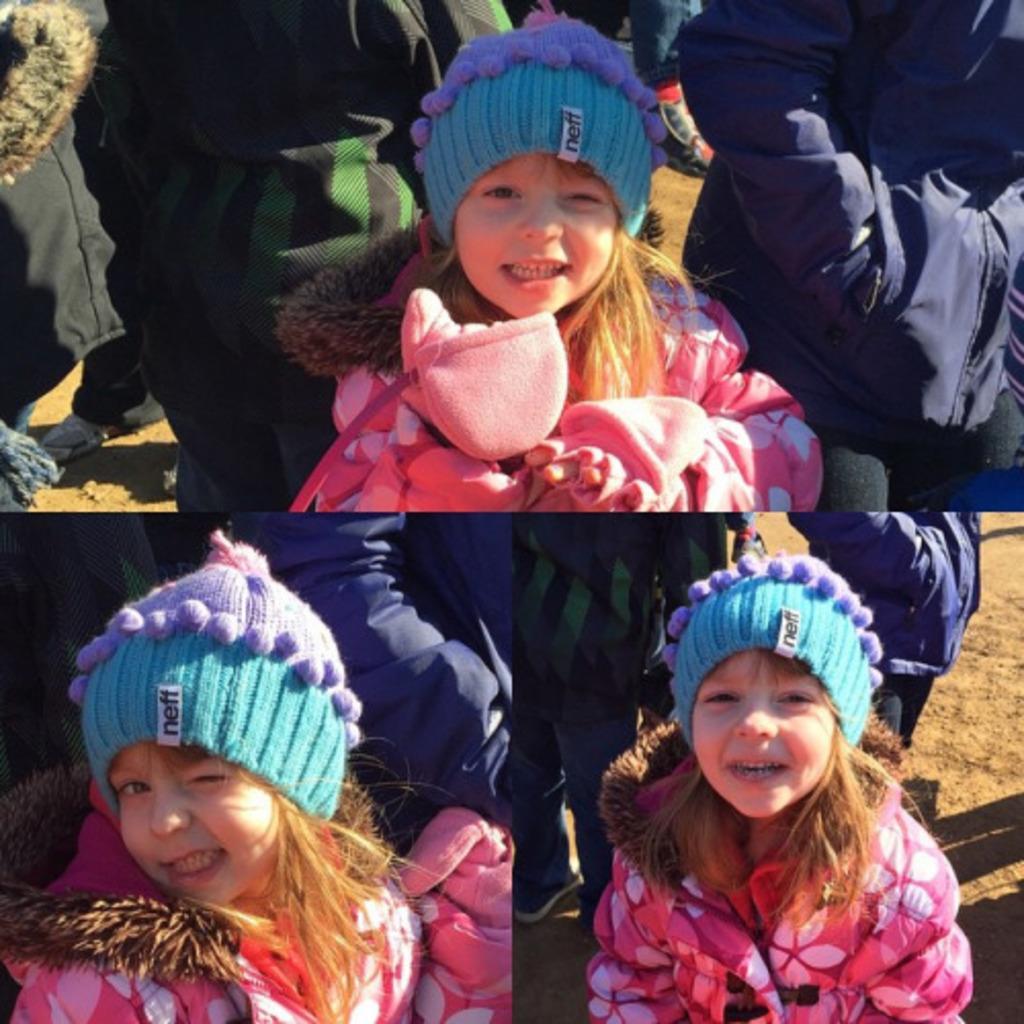In one or two sentences, can you explain what this image depicts? In the image I can see the collage of three pictures in which there is a little girl wearing jacket, cap and behind there are some other people. 